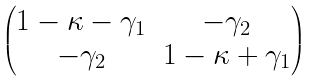<formula> <loc_0><loc_0><loc_500><loc_500>\begin{pmatrix} 1 - \kappa - \gamma _ { 1 } & - \gamma _ { 2 } \\ - \gamma _ { 2 } & 1 - \kappa + \gamma _ { 1 } \end{pmatrix}</formula> 